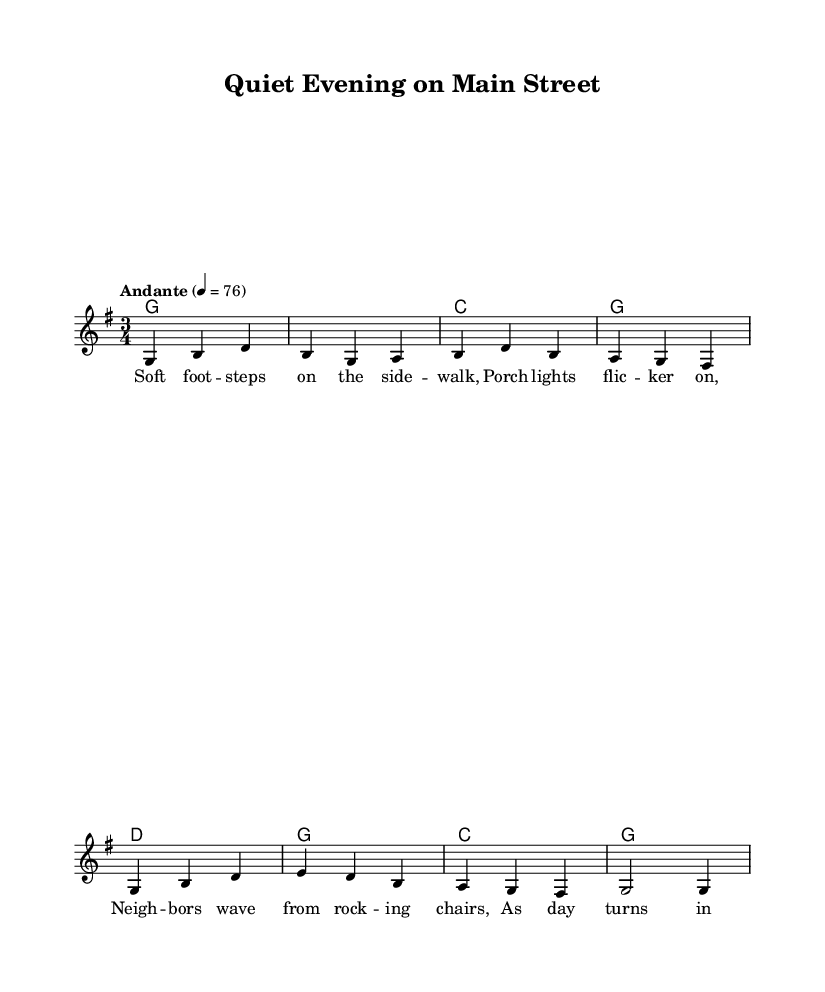What is the key signature of this music? The key signature is G major, which has one sharp (F#) noted at the beginning of the staff.
Answer: G major What is the time signature of this piece? The time signature is found at the beginning of the sheet music, indicating how many beats are in each measure. In this case, it shows 3/4, meaning there are three quarter-note beats per measure.
Answer: 3/4 What is the tempo marking for this piece? The tempo marking is written as "Andante" with a metronome marking of 76. "Andante" generally indicates a walking pace, and the number indicates the speed in beats per minute.
Answer: Andante 4 = 76 How many measures are in the melody? The melody consists of a total of 8 measures, as counted from the beginning to the end of the music staff.
Answer: 8 What type of song is "Quiet Evening on Main Street"? Given the title and lyrics that reflect community and small-town life, it is categorized as a folk song. Folk songs often celebrate communal values and everyday experiences.
Answer: Folk song Which chords are used in the harmonies? The harmonies include G, C, and D chords, as noted in the chord mode section, with G being the tonic, C as the subdominant, and D as the dominant.
Answer: G, C, D 